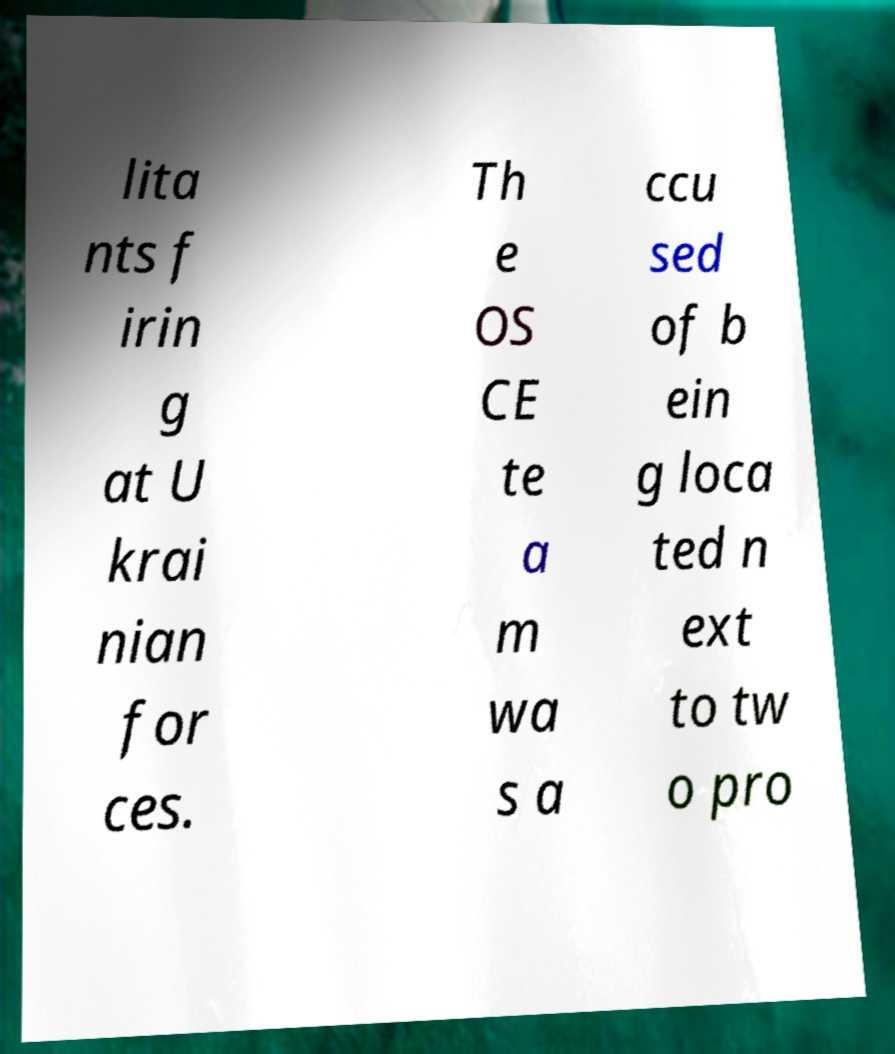Can you read and provide the text displayed in the image?This photo seems to have some interesting text. Can you extract and type it out for me? lita nts f irin g at U krai nian for ces. Th e OS CE te a m wa s a ccu sed of b ein g loca ted n ext to tw o pro 